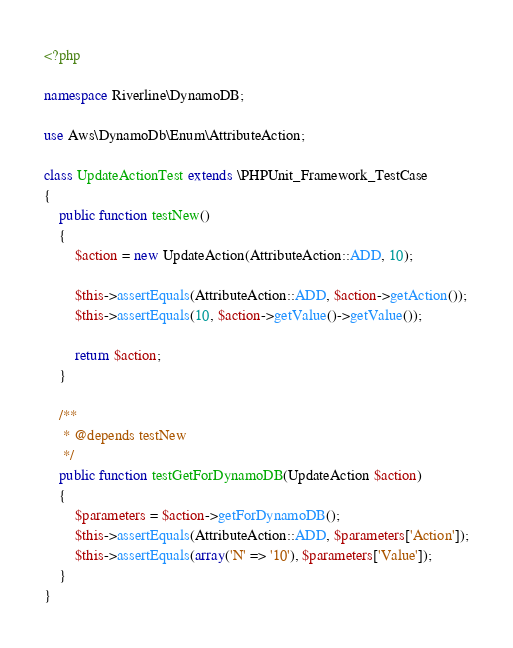<code> <loc_0><loc_0><loc_500><loc_500><_PHP_><?php

namespace Riverline\DynamoDB;

use Aws\DynamoDb\Enum\AttributeAction;

class UpdateActionTest extends \PHPUnit_Framework_TestCase
{
    public function testNew()
    {
        $action = new UpdateAction(AttributeAction::ADD, 10);

        $this->assertEquals(AttributeAction::ADD, $action->getAction());
        $this->assertEquals(10, $action->getValue()->getValue());

        return $action;
    }

    /**
     * @depends testNew
     */
    public function testGetForDynamoDB(UpdateAction $action)
    {
        $parameters = $action->getForDynamoDB();
        $this->assertEquals(AttributeAction::ADD, $parameters['Action']);
        $this->assertEquals(array('N' => '10'), $parameters['Value']);
    }
}</code> 